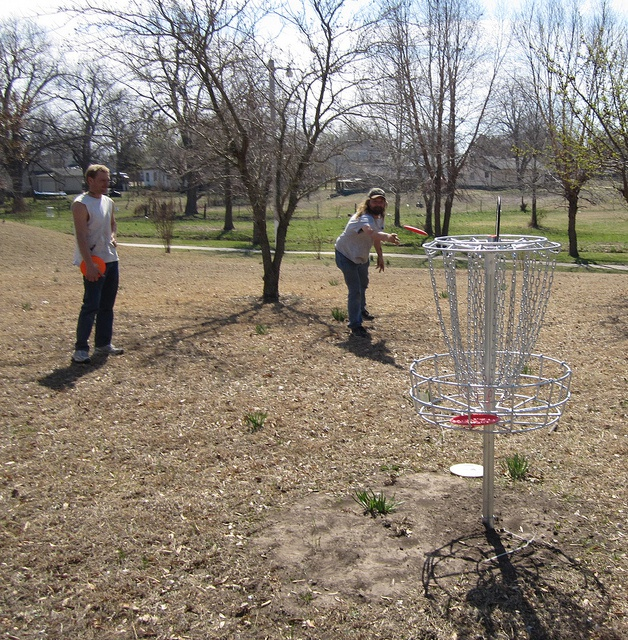Describe the objects in this image and their specific colors. I can see people in white, black, gray, and maroon tones, people in white, black, gray, maroon, and darkgray tones, frisbee in white, brown, lightpink, and maroon tones, frisbee in white, darkgray, gray, and black tones, and frisbee in white, brown, and maroon tones in this image. 